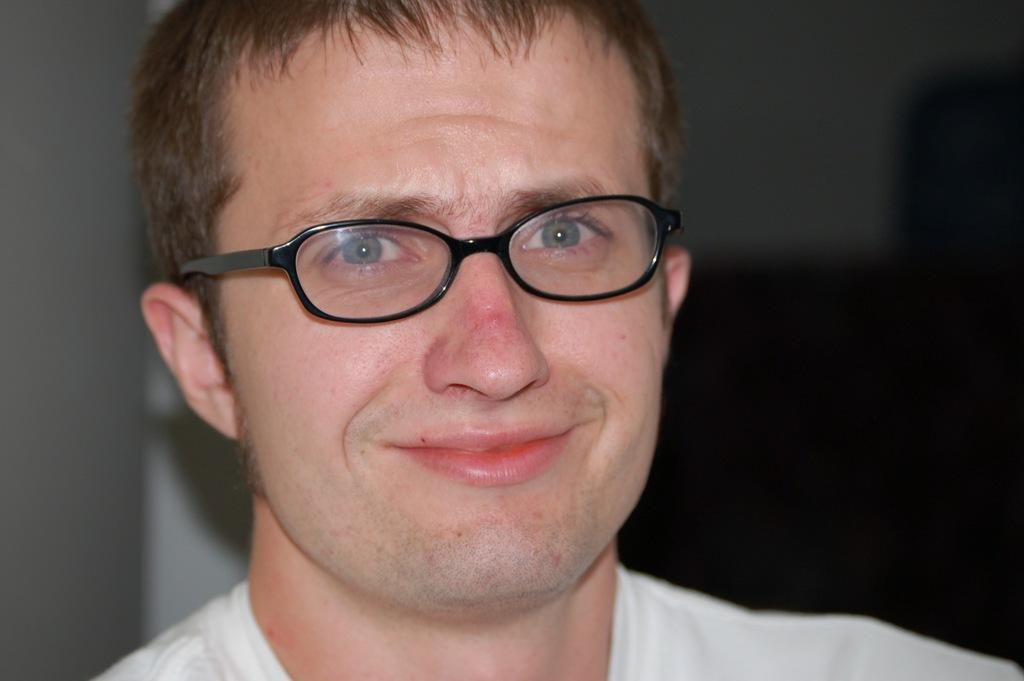Who is present in the image? There is a man in the image. What is the man wearing on his face? The man is wearing spectacles. What type of attraction is the man visiting in the image? There is no indication of an attraction in the image; it only shows a man wearing spectacles. 